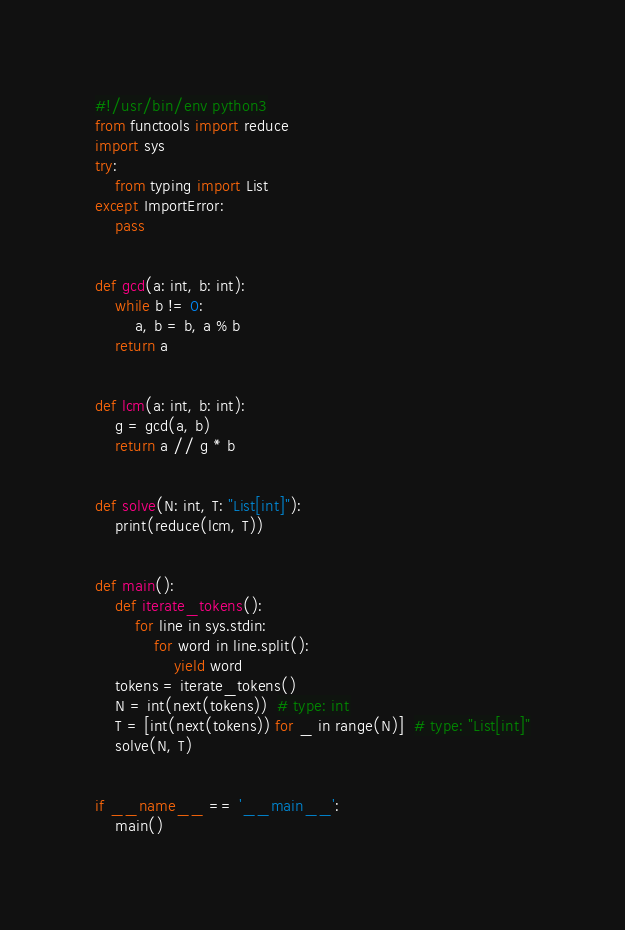<code> <loc_0><loc_0><loc_500><loc_500><_Python_>#!/usr/bin/env python3
from functools import reduce
import sys
try:
    from typing import List
except ImportError:
    pass


def gcd(a: int, b: int):
    while b != 0:
        a, b = b, a % b
    return a


def lcm(a: int, b: int):
    g = gcd(a, b)
    return a // g * b


def solve(N: int, T: "List[int]"):
    print(reduce(lcm, T))


def main():
    def iterate_tokens():
        for line in sys.stdin:
            for word in line.split():
                yield word
    tokens = iterate_tokens()
    N = int(next(tokens))  # type: int
    T = [int(next(tokens)) for _ in range(N)]  # type: "List[int]"
    solve(N, T)


if __name__ == '__main__':
    main()
</code> 